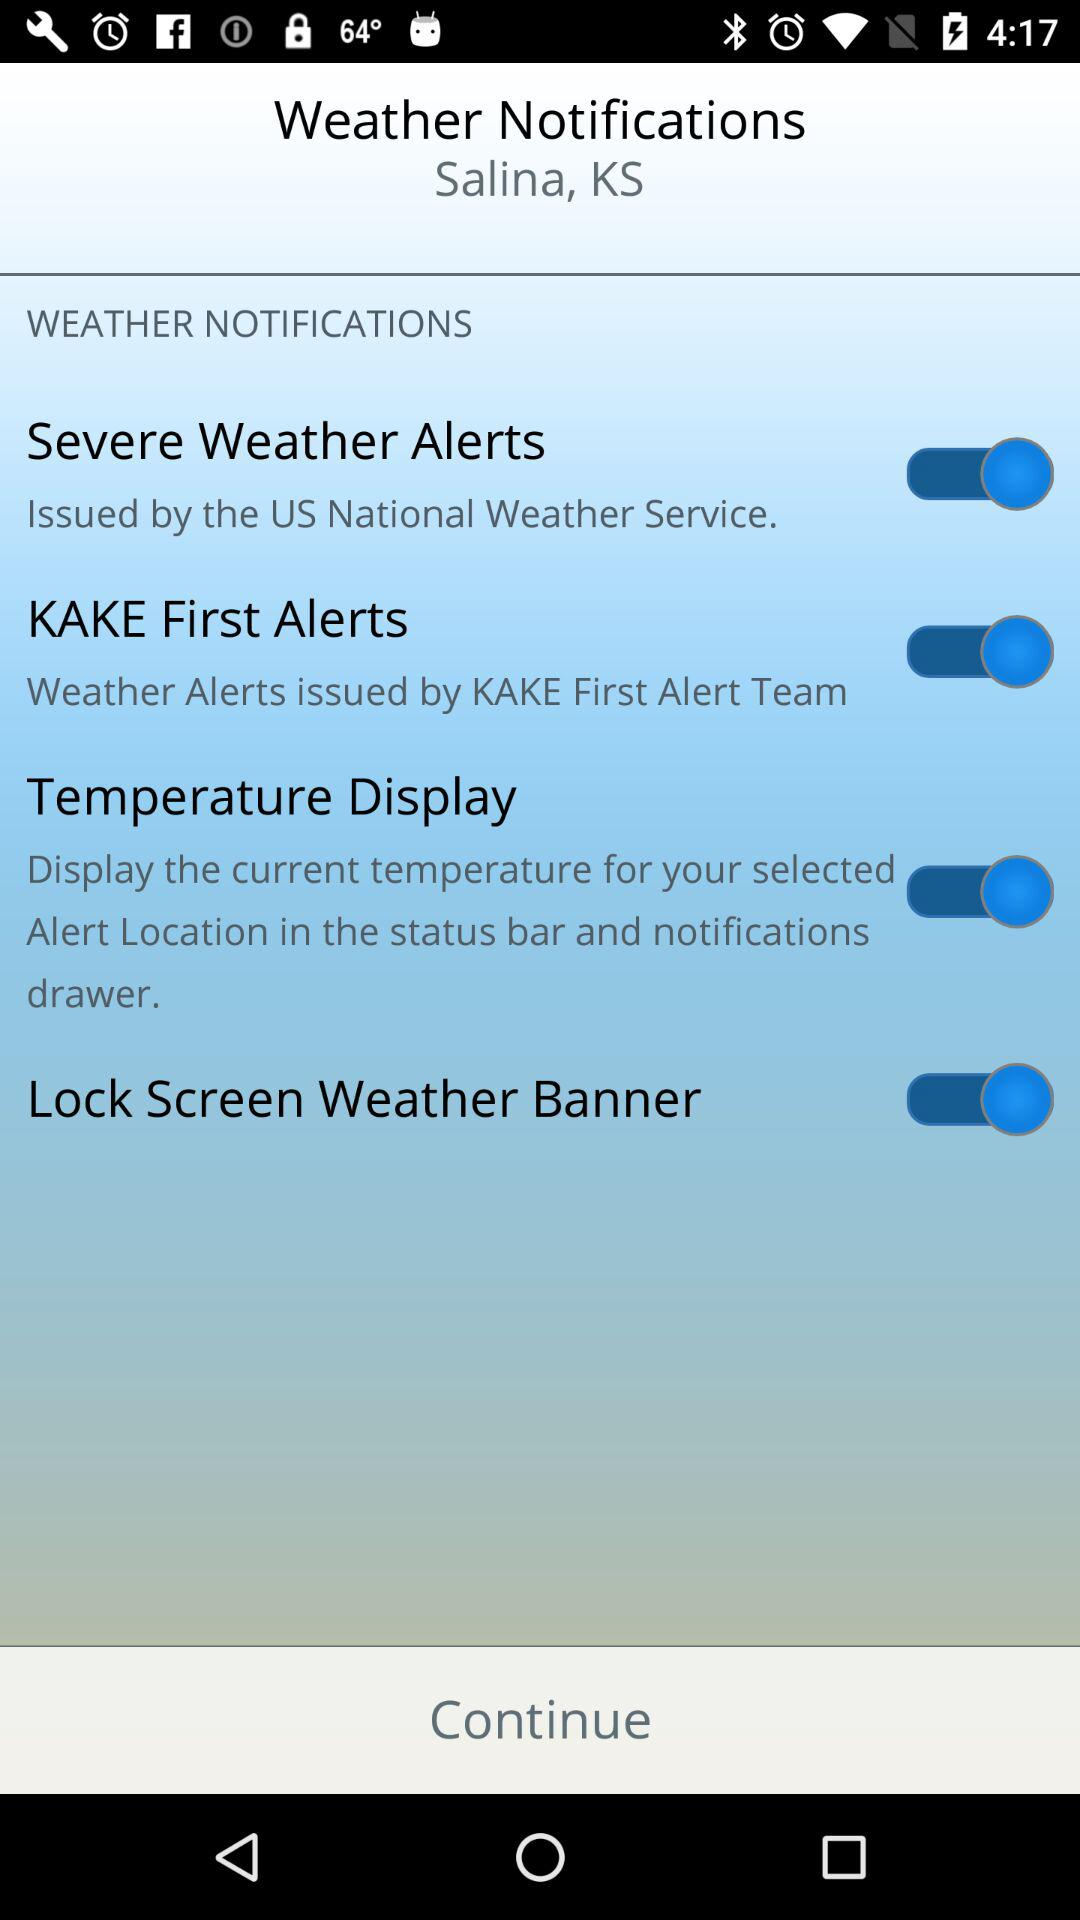What is the location for the weather notification? The location is Salina, KS. 